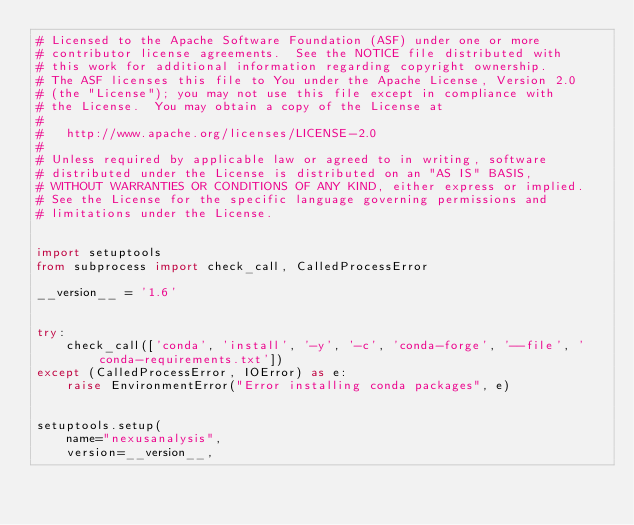Convert code to text. <code><loc_0><loc_0><loc_500><loc_500><_Python_># Licensed to the Apache Software Foundation (ASF) under one or more
# contributor license agreements.  See the NOTICE file distributed with
# this work for additional information regarding copyright ownership.
# The ASF licenses this file to You under the Apache License, Version 2.0
# (the "License"); you may not use this file except in compliance with
# the License.  You may obtain a copy of the License at
#
#   http://www.apache.org/licenses/LICENSE-2.0
#
# Unless required by applicable law or agreed to in writing, software
# distributed under the License is distributed on an "AS IS" BASIS,
# WITHOUT WARRANTIES OR CONDITIONS OF ANY KIND, either express or implied.
# See the License for the specific language governing permissions and
# limitations under the License.


import setuptools
from subprocess import check_call, CalledProcessError

__version__ = '1.6'


try:
    check_call(['conda', 'install', '-y', '-c', 'conda-forge', '--file', 'conda-requirements.txt'])
except (CalledProcessError, IOError) as e:
    raise EnvironmentError("Error installing conda packages", e)


setuptools.setup(
    name="nexusanalysis",
    version=__version__,</code> 